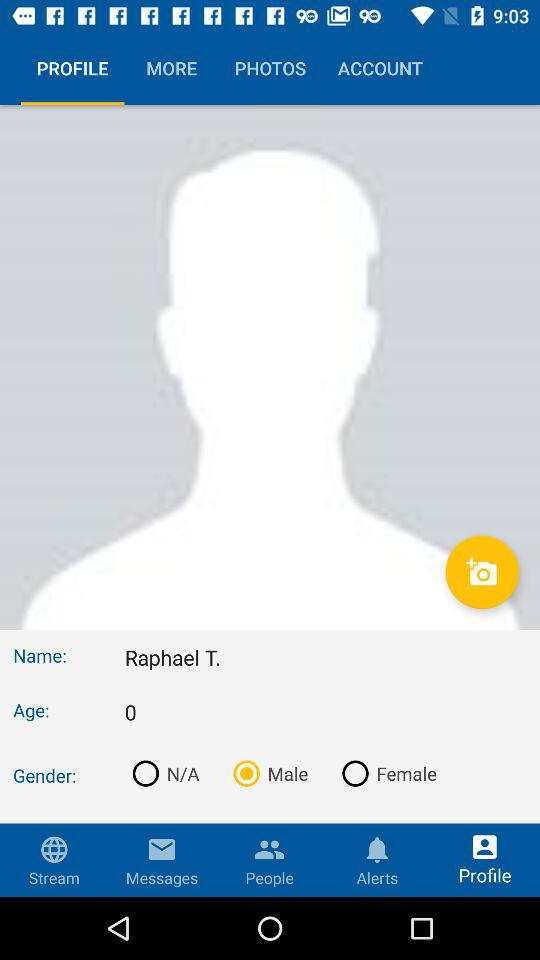How many options are there for the gender field?
Answer the question using a single word or phrase. 3 